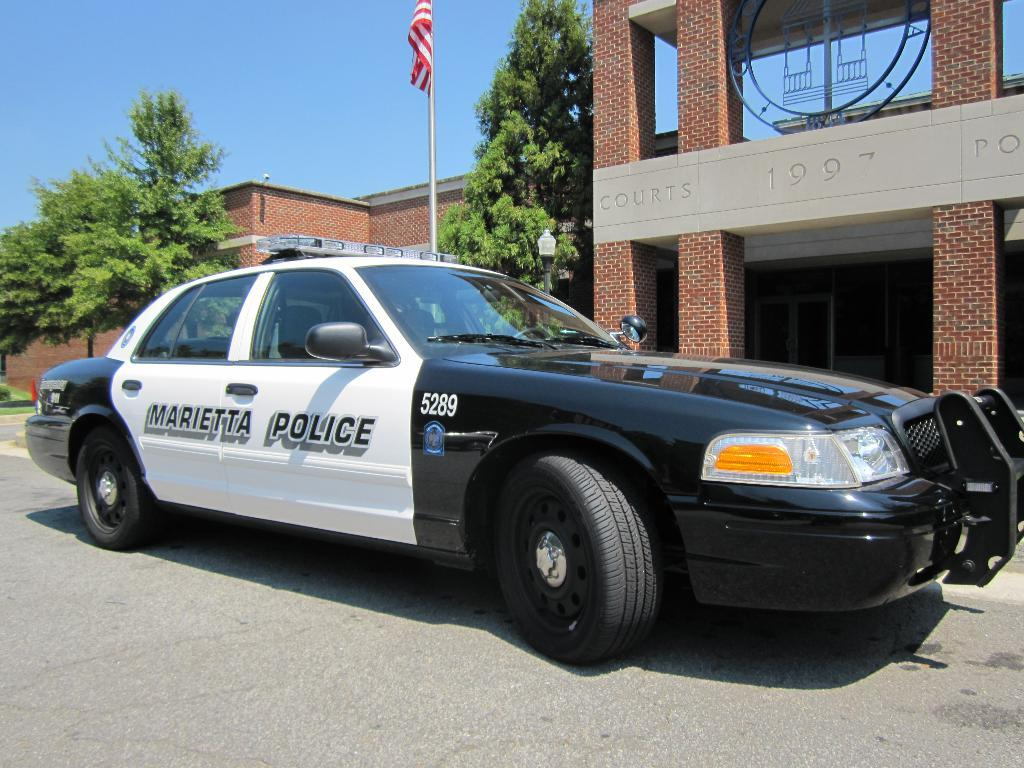Provide a one-sentence caption for the provided image. A marietta police vehicle infront of the court house. 